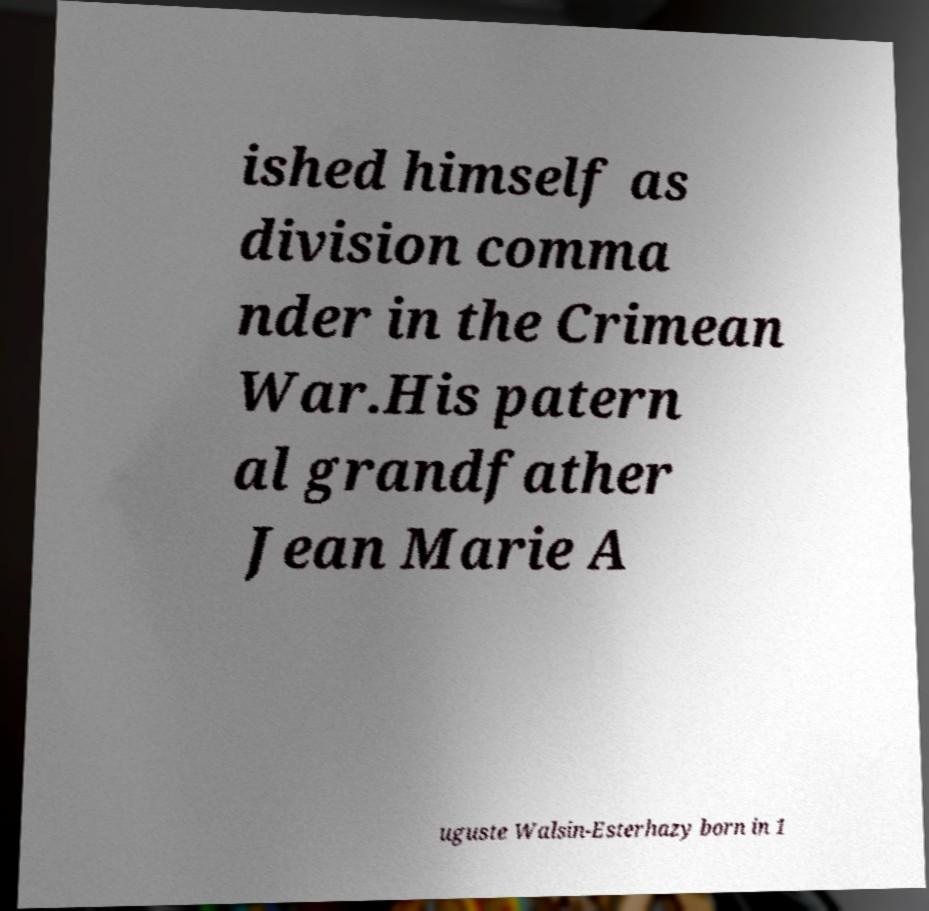What messages or text are displayed in this image? I need them in a readable, typed format. ished himself as division comma nder in the Crimean War.His patern al grandfather Jean Marie A uguste Walsin-Esterhazy born in 1 